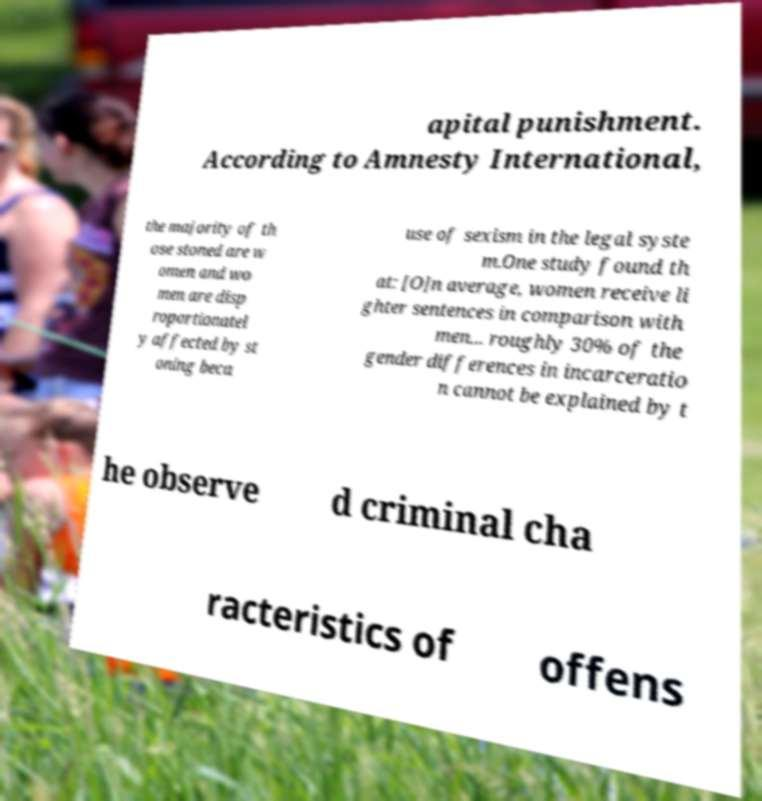Could you extract and type out the text from this image? apital punishment. According to Amnesty International, the majority of th ose stoned are w omen and wo men are disp roportionatel y affected by st oning beca use of sexism in the legal syste m.One study found th at: [O]n average, women receive li ghter sentences in comparison with men... roughly 30% of the gender differences in incarceratio n cannot be explained by t he observe d criminal cha racteristics of offens 